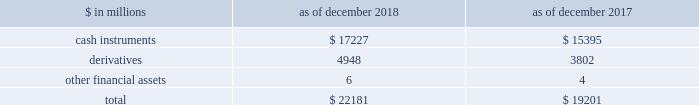The goldman sachs group , inc .
And subsidiaries notes to consolidated financial statements the table below presents a summary of level 3 financial assets. .
Level 3 financial assets as of december 2018 increased compared with december 2017 , primarily reflecting an increase in level 3 cash instruments .
See notes 6 through 8 for further information about level 3 financial assets ( including information about unrealized gains and losses related to level 3 financial assets and financial liabilities , and transfers in and out of level 3 ) .
Note 6 .
Cash instruments cash instruments include u.s .
Government and agency obligations , non-u.s .
Government and agency obligations , mortgage-backed loans and securities , corporate debt instruments , equity securities , investments in funds at nav , and other non-derivative financial instruments owned and financial instruments sold , but not yet purchased .
See below for the types of cash instruments included in each level of the fair value hierarchy and the valuation techniques and significant inputs used to determine their fair values .
See note 5 for an overview of the firm 2019s fair value measurement policies .
Level 1 cash instruments level 1 cash instruments include certain money market instruments , u.s .
Government obligations , most non-u.s .
Government obligations , certain government agency obligations , certain corporate debt instruments and actively traded listed equities .
These instruments are valued using quoted prices for identical unrestricted instruments in active markets .
The firm defines active markets for equity instruments based on the average daily trading volume both in absolute terms and relative to the market capitalization for the instrument .
The firm defines active markets for debt instruments based on both the average daily trading volume and the number of days with trading activity .
Level 2 cash instruments level 2 cash instruments include most money market instruments , most government agency obligations , certain non-u.s .
Government obligations , most mortgage-backed loans and securities , most corporate debt instruments , most state and municipal obligations , most other debt obligations , restricted or less liquid listed equities , commodities and certain lending commitments .
Valuations of level 2 cash instruments can be verified to quoted prices , recent trading activity for identical or similar instruments , broker or dealer quotations or alternative pricing sources with reasonable levels of price transparency .
Consideration is given to the nature of the quotations ( e.g. , indicative or firm ) and the relationship of recent market activity to the prices provided from alternative pricing sources .
Valuation adjustments are typically made to level 2 cash instruments ( i ) if the cash instrument is subject to transfer restrictions and/or ( ii ) for other premiums and liquidity discounts that a market participant would require to arrive at fair value .
Valuation adjustments are generally based on market evidence .
Level 3 cash instruments level 3 cash instruments have one or more significant valuation inputs that are not observable .
Absent evidence to the contrary , level 3 cash instruments are initially valued at transaction price , which is considered to be the best initial estimate of fair value .
Subsequently , the firm uses other methodologies to determine fair value , which vary based on the type of instrument .
Valuation inputs and assumptions are changed when corroborated by substantive observable evidence , including values realized on sales .
Valuation techniques and significant inputs of level 3 cash instruments valuation techniques of level 3 cash instruments vary by instrument , but are generally based on discounted cash flow techniques .
The valuation techniques and the nature of significant inputs used to determine the fair values of each type of level 3 cash instrument are described below : loans and securities backed by commercial real estate .
Loans and securities backed by commercial real estate are directly or indirectly collateralized by a single commercial real estate property or a portfolio of properties , and may include tranches of varying levels of subordination .
Significant inputs are generally determined based on relative value analyses and include : 2030 market yields implied by transactions of similar or related assets and/or current levels and changes in market indices such as the cmbx ( an index that tracks the performance of commercial mortgage bonds ) ; 118 goldman sachs 2018 form 10-k .
What is the percentage change in cash instruments from 2017 to 2018? 
Computations: ((17227 - 15395) / 15395)
Answer: 0.119. The goldman sachs group , inc .
And subsidiaries notes to consolidated financial statements the table below presents a summary of level 3 financial assets. .
Level 3 financial assets as of december 2018 increased compared with december 2017 , primarily reflecting an increase in level 3 cash instruments .
See notes 6 through 8 for further information about level 3 financial assets ( including information about unrealized gains and losses related to level 3 financial assets and financial liabilities , and transfers in and out of level 3 ) .
Note 6 .
Cash instruments cash instruments include u.s .
Government and agency obligations , non-u.s .
Government and agency obligations , mortgage-backed loans and securities , corporate debt instruments , equity securities , investments in funds at nav , and other non-derivative financial instruments owned and financial instruments sold , but not yet purchased .
See below for the types of cash instruments included in each level of the fair value hierarchy and the valuation techniques and significant inputs used to determine their fair values .
See note 5 for an overview of the firm 2019s fair value measurement policies .
Level 1 cash instruments level 1 cash instruments include certain money market instruments , u.s .
Government obligations , most non-u.s .
Government obligations , certain government agency obligations , certain corporate debt instruments and actively traded listed equities .
These instruments are valued using quoted prices for identical unrestricted instruments in active markets .
The firm defines active markets for equity instruments based on the average daily trading volume both in absolute terms and relative to the market capitalization for the instrument .
The firm defines active markets for debt instruments based on both the average daily trading volume and the number of days with trading activity .
Level 2 cash instruments level 2 cash instruments include most money market instruments , most government agency obligations , certain non-u.s .
Government obligations , most mortgage-backed loans and securities , most corporate debt instruments , most state and municipal obligations , most other debt obligations , restricted or less liquid listed equities , commodities and certain lending commitments .
Valuations of level 2 cash instruments can be verified to quoted prices , recent trading activity for identical or similar instruments , broker or dealer quotations or alternative pricing sources with reasonable levels of price transparency .
Consideration is given to the nature of the quotations ( e.g. , indicative or firm ) and the relationship of recent market activity to the prices provided from alternative pricing sources .
Valuation adjustments are typically made to level 2 cash instruments ( i ) if the cash instrument is subject to transfer restrictions and/or ( ii ) for other premiums and liquidity discounts that a market participant would require to arrive at fair value .
Valuation adjustments are generally based on market evidence .
Level 3 cash instruments level 3 cash instruments have one or more significant valuation inputs that are not observable .
Absent evidence to the contrary , level 3 cash instruments are initially valued at transaction price , which is considered to be the best initial estimate of fair value .
Subsequently , the firm uses other methodologies to determine fair value , which vary based on the type of instrument .
Valuation inputs and assumptions are changed when corroborated by substantive observable evidence , including values realized on sales .
Valuation techniques and significant inputs of level 3 cash instruments valuation techniques of level 3 cash instruments vary by instrument , but are generally based on discounted cash flow techniques .
The valuation techniques and the nature of significant inputs used to determine the fair values of each type of level 3 cash instrument are described below : loans and securities backed by commercial real estate .
Loans and securities backed by commercial real estate are directly or indirectly collateralized by a single commercial real estate property or a portfolio of properties , and may include tranches of varying levels of subordination .
Significant inputs are generally determined based on relative value analyses and include : 2030 market yields implied by transactions of similar or related assets and/or current levels and changes in market indices such as the cmbx ( an index that tracks the performance of commercial mortgage bonds ) ; 118 goldman sachs 2018 form 10-k .
For level 3 financial assets in millions , for 2018 and 2017 , what was the largest balance of cash instruments? 
Computations: table_max(cash instruments, none)
Answer: 17227.0. 